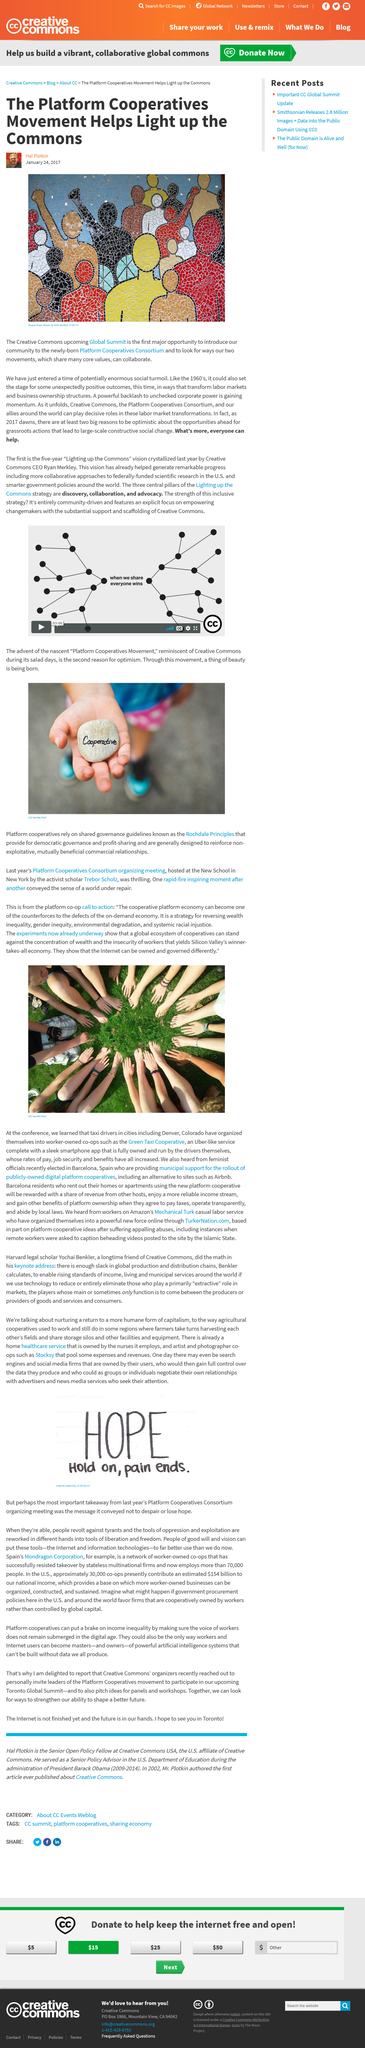Indicate a few pertinent items in this graphic. The artwork in the article is named "People Power Mosaic. The author of this article is Hal Plotkin. At the upcoming Global Summit of The Creative Commons, a new community will be introduced: the Platform Cooperatives Consortium. 